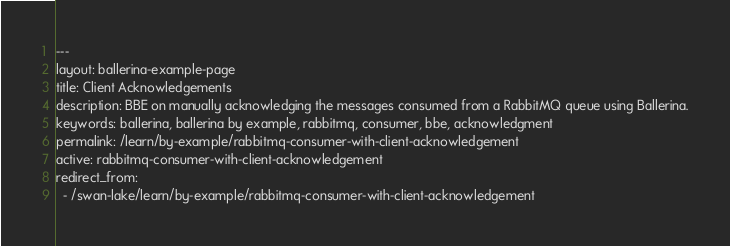Convert code to text. <code><loc_0><loc_0><loc_500><loc_500><_HTML_>---
layout: ballerina-example-page
title: Client Acknowledgements
description: BBE on manually acknowledging the messages consumed from a RabbitMQ queue using Ballerina.
keywords: ballerina, ballerina by example, rabbitmq, consumer, bbe, acknowledgment
permalink: /learn/by-example/rabbitmq-consumer-with-client-acknowledgement
active: rabbitmq-consumer-with-client-acknowledgement
redirect_from:
  - /swan-lake/learn/by-example/rabbitmq-consumer-with-client-acknowledgement</code> 